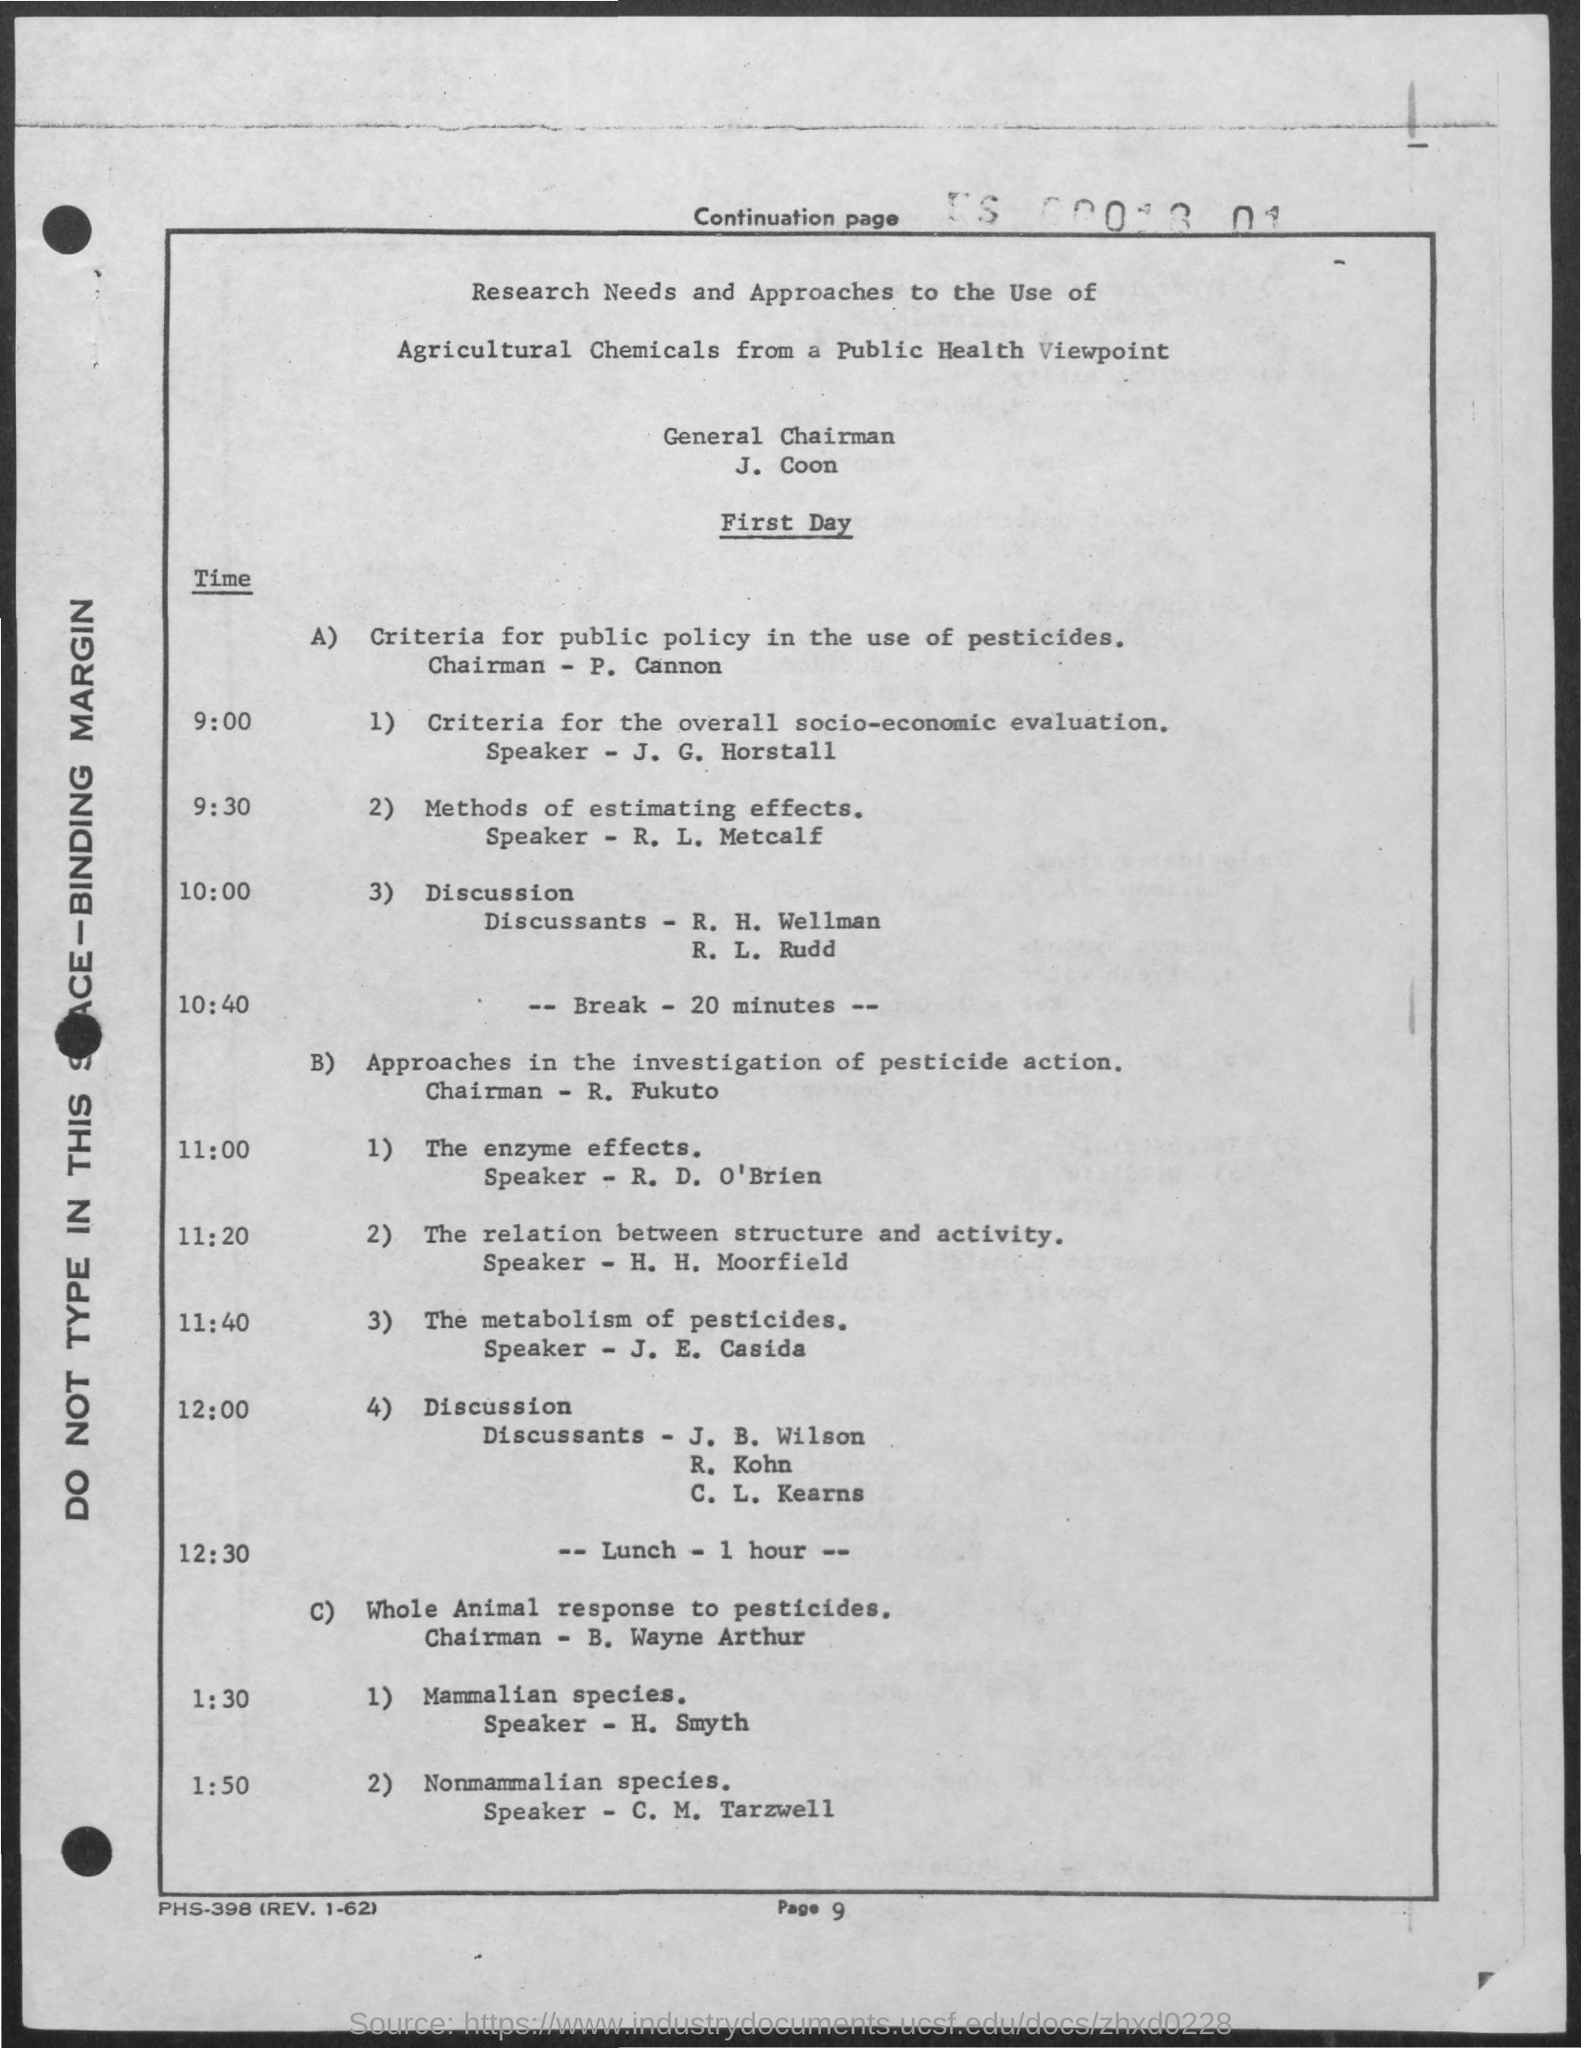Indicate a few pertinent items in this graphic. The speaker of the presentation "The Metabolism of Pesticides" is J. E. Casida. The page number is 9. The General Chairman is J. Coon. 